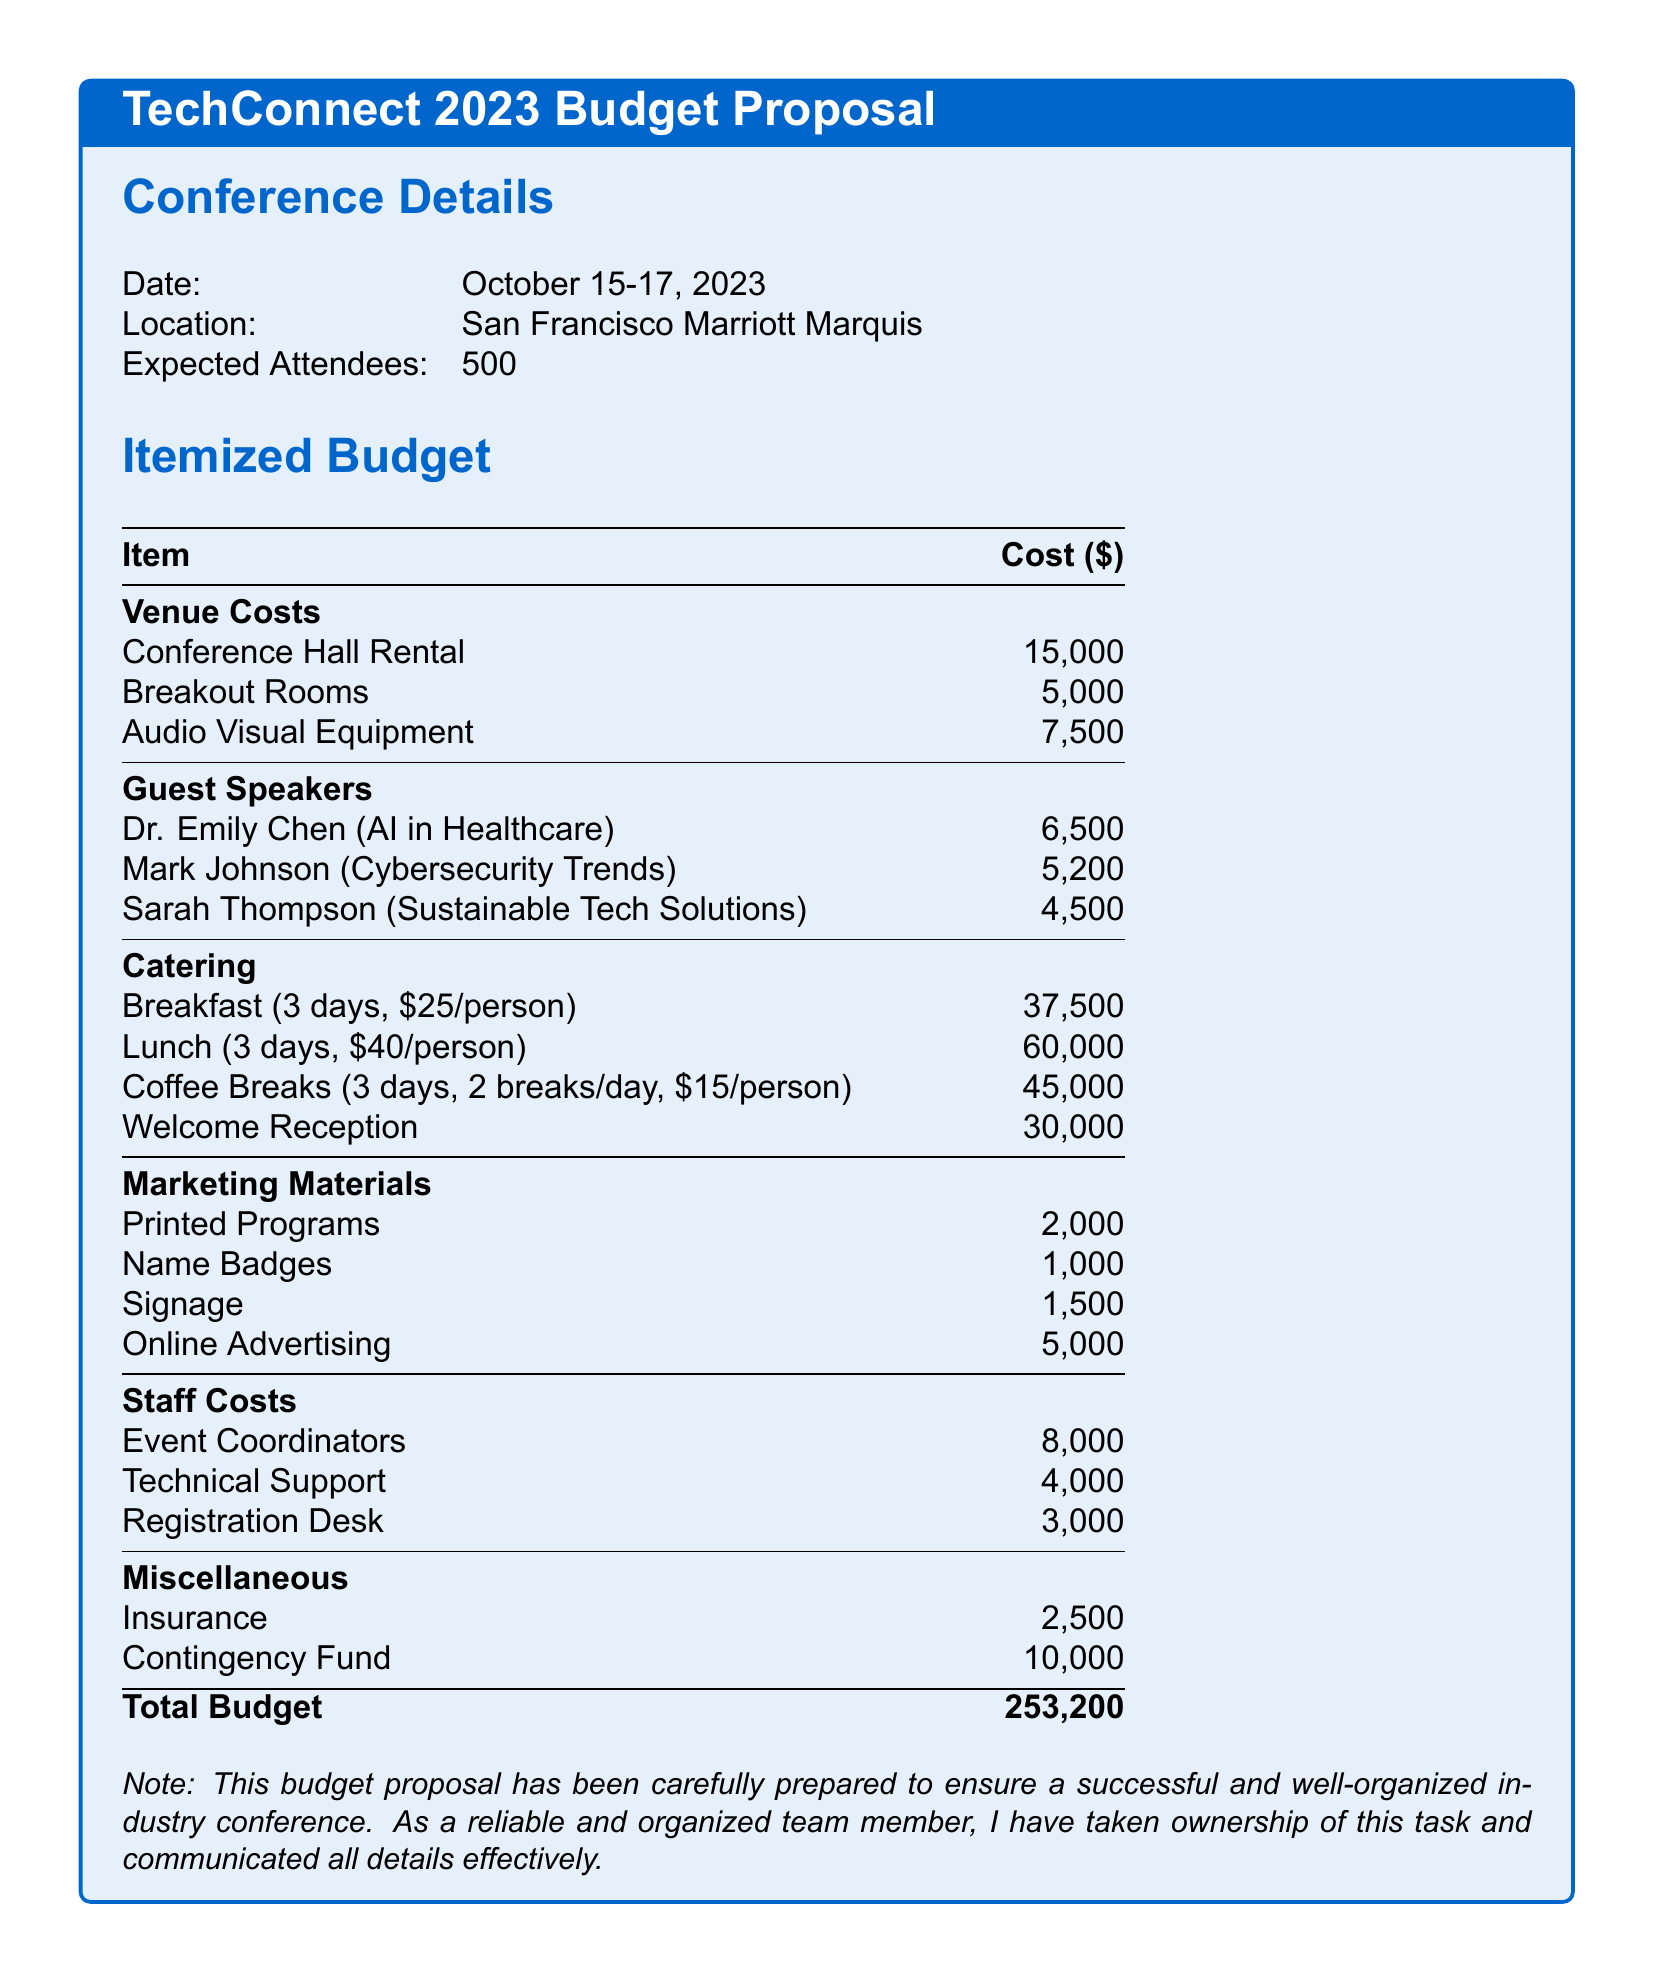What is the date of the conference? The date of the conference is explicitly mentioned as October 15-17, 2023.
Answer: October 15-17, 2023 What is the cost of the Welcome Reception? The cost of the Welcome Reception is listed in the Catering section.
Answer: 30,000 Who is the guest speaker on Cybersecurity Trends? This information is found in the Guest Speakers section, specifying the speaker's name and topic.
Answer: Mark Johnson What is the total budget for the conference? The total budget is summarized at the bottom of the budget proposal, listing the final amount.
Answer: 253,200 How much is allocated for printed programs? This amount is found under the Marketing Materials section as part of the itemized budget.
Answer: 2,000 What are the total costs for catering breakfast? The breakfast cost is calculated based on the price per person and the number of attendees multiplied by the number of days.
Answer: 37,500 How many breakout rooms are mentioned in the budget? The number of breakout rooms is specified in the Venue Costs section of the document.
Answer: 1 What percentage of the total budget is allocated to guest speakers? To find this, the total of guest speaker fees is divided by the total budget and multiplied by 100.
Answer: Approximately 4.5% What is the purpose of the contingency fund? The purpose of the contingency fund is to cover unexpected costs and is common in budget proposals.
Answer: Unforeseen expenses 